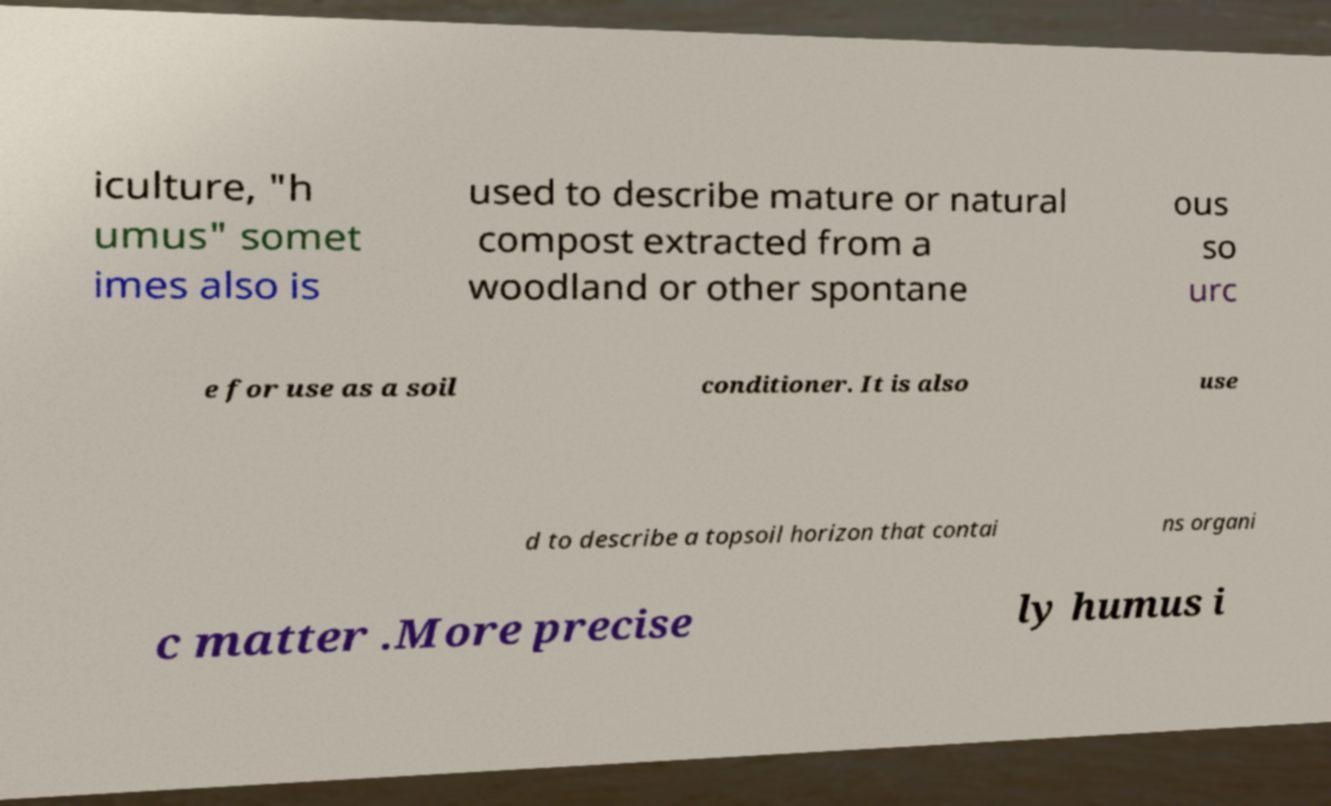There's text embedded in this image that I need extracted. Can you transcribe it verbatim? iculture, "h umus" somet imes also is used to describe mature or natural compost extracted from a woodland or other spontane ous so urc e for use as a soil conditioner. It is also use d to describe a topsoil horizon that contai ns organi c matter .More precise ly humus i 